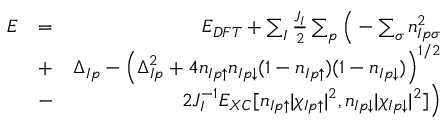<formula> <loc_0><loc_0><loc_500><loc_500>\begin{array} { r l r } { E } & { = } & { E _ { D F T } + \sum _ { I } \frac { J _ { I } } { 2 } \sum _ { p } \left ( - \sum _ { \sigma } n _ { I p \sigma } ^ { 2 } } \\ & { + } & { \Delta _ { I p } - \left ( \Delta _ { I p } ^ { 2 } + 4 n _ { I p \uparrow } n _ { I p \downarrow } ( 1 - n _ { I p \uparrow } ) ( 1 - n _ { I p \downarrow } ) \right ) ^ { 1 / 2 } } \\ & { - } & { 2 J _ { I } ^ { - 1 } E _ { X C } [ n _ { I p \uparrow } | \chi _ { I p \uparrow } | ^ { 2 } , n _ { I p \downarrow } | \chi _ { I p \downarrow } | ^ { 2 } ] \right ) } \end{array}</formula> 